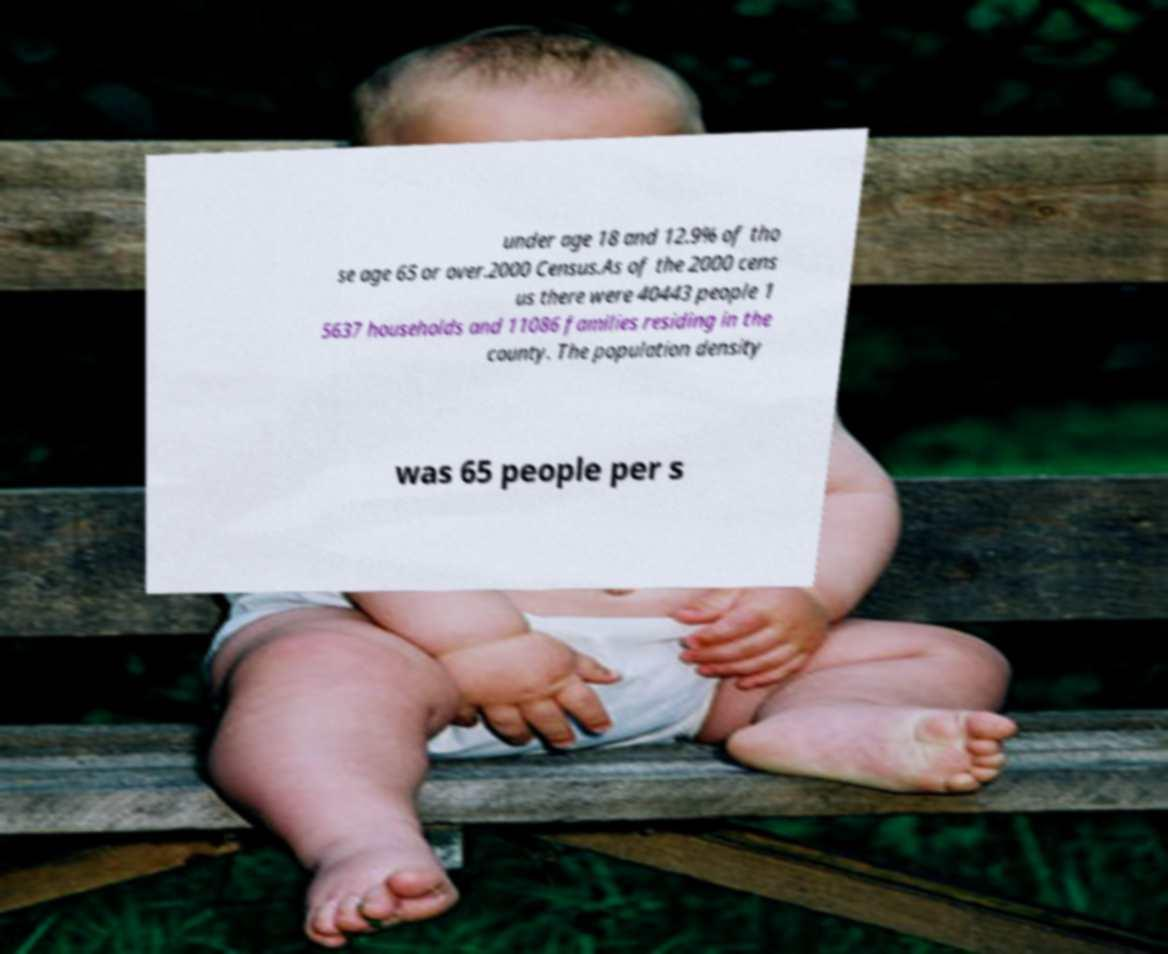I need the written content from this picture converted into text. Can you do that? under age 18 and 12.9% of tho se age 65 or over.2000 Census.As of the 2000 cens us there were 40443 people 1 5637 households and 11086 families residing in the county. The population density was 65 people per s 